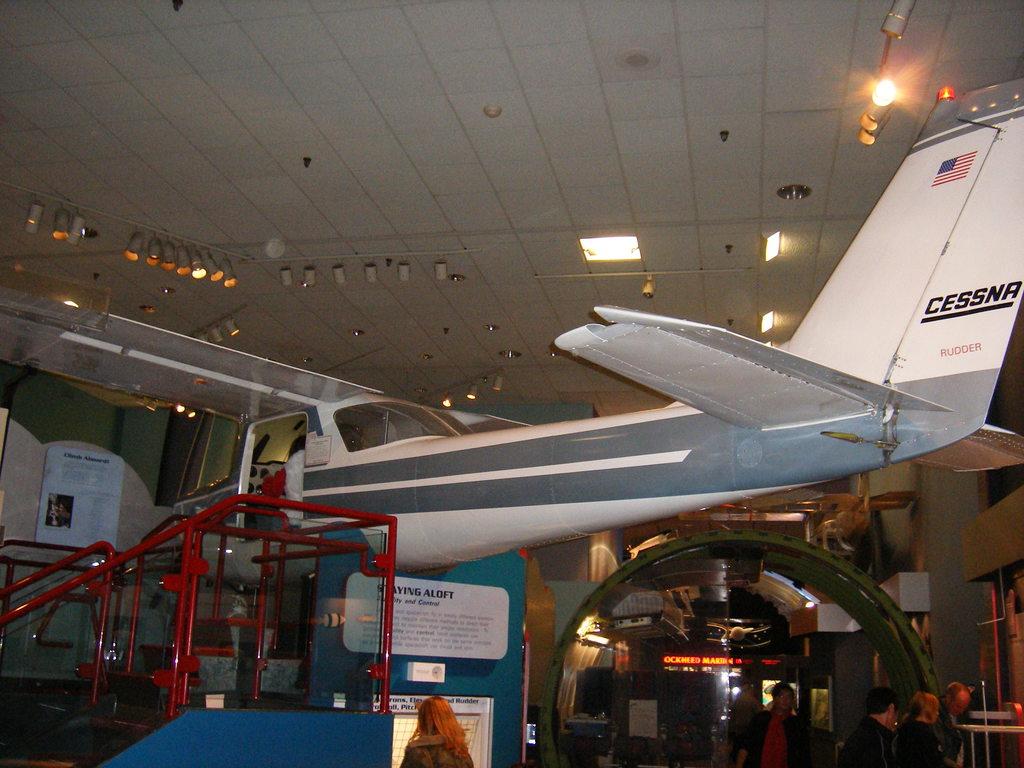What type of plane is this?
Offer a terse response. Cessna. What part of the plane is labeled below the manufacturer name?
Your answer should be very brief. Rudder. 